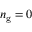Convert formula to latex. <formula><loc_0><loc_0><loc_500><loc_500>n _ { g } = 0</formula> 